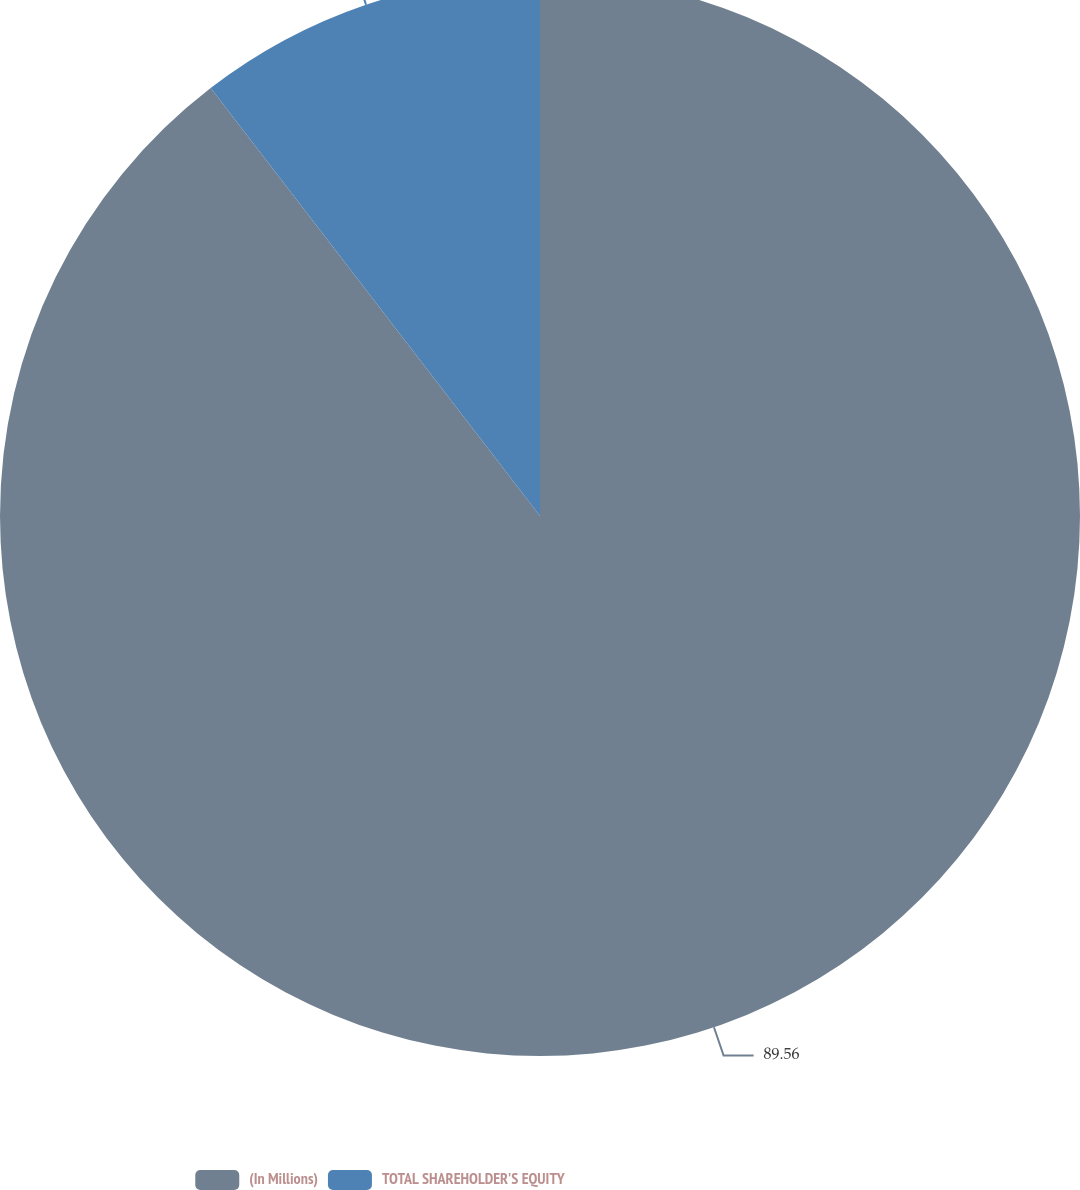Convert chart to OTSL. <chart><loc_0><loc_0><loc_500><loc_500><pie_chart><fcel>(In Millions)<fcel>TOTAL SHAREHOLDER'S EQUITY<nl><fcel>89.56%<fcel>10.44%<nl></chart> 